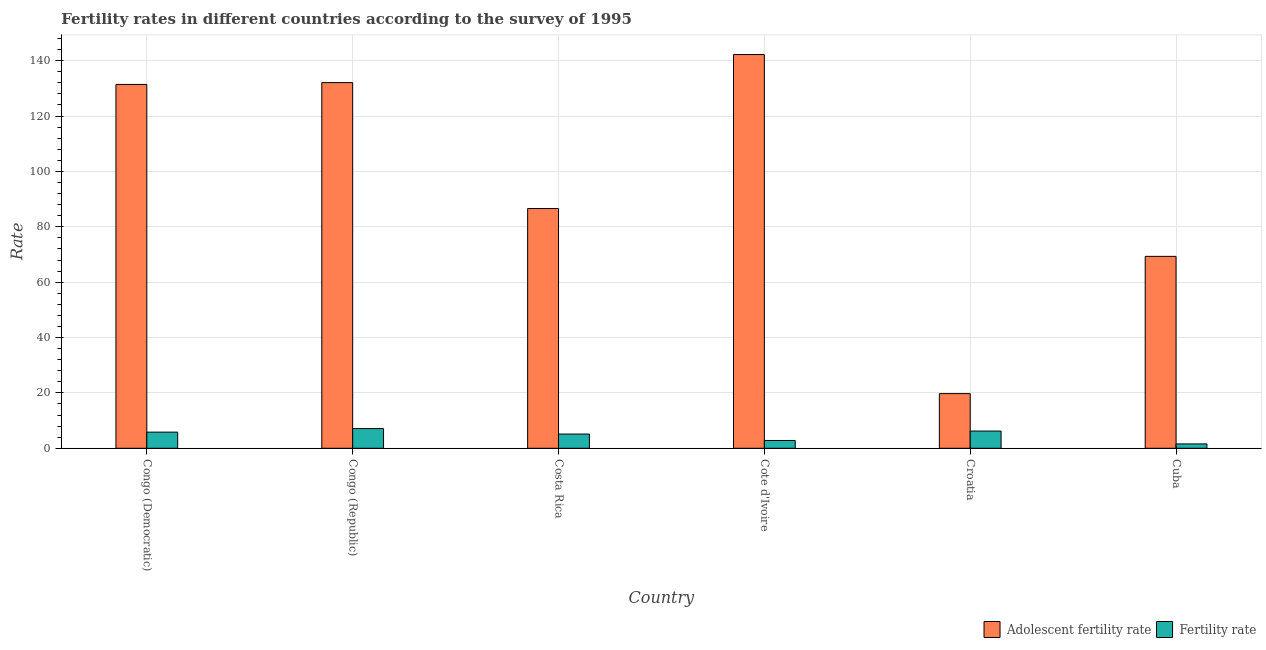How many groups of bars are there?
Provide a short and direct response. 6. Are the number of bars per tick equal to the number of legend labels?
Your response must be concise. Yes. Are the number of bars on each tick of the X-axis equal?
Keep it short and to the point. Yes. How many bars are there on the 5th tick from the right?
Your response must be concise. 2. What is the label of the 4th group of bars from the left?
Offer a very short reply. Cote d'Ivoire. In how many cases, is the number of bars for a given country not equal to the number of legend labels?
Your response must be concise. 0. What is the adolescent fertility rate in Congo (Democratic)?
Offer a very short reply. 131.42. Across all countries, what is the maximum adolescent fertility rate?
Keep it short and to the point. 142.21. Across all countries, what is the minimum fertility rate?
Ensure brevity in your answer.  1.58. In which country was the adolescent fertility rate maximum?
Offer a terse response. Cote d'Ivoire. In which country was the fertility rate minimum?
Keep it short and to the point. Cuba. What is the total adolescent fertility rate in the graph?
Make the answer very short. 581.38. What is the difference between the fertility rate in Congo (Democratic) and that in Cuba?
Keep it short and to the point. 4.25. What is the difference between the adolescent fertility rate in Cuba and the fertility rate in Costa Rica?
Offer a very short reply. 64.18. What is the average fertility rate per country?
Provide a short and direct response. 4.79. What is the difference between the fertility rate and adolescent fertility rate in Costa Rica?
Your answer should be very brief. -81.46. In how many countries, is the adolescent fertility rate greater than 12 ?
Offer a terse response. 6. What is the ratio of the fertility rate in Congo (Republic) to that in Cuba?
Give a very brief answer. 4.51. Is the fertility rate in Costa Rica less than that in Cote d'Ivoire?
Offer a very short reply. No. Is the difference between the adolescent fertility rate in Costa Rica and Croatia greater than the difference between the fertility rate in Costa Rica and Croatia?
Provide a succinct answer. Yes. What is the difference between the highest and the second highest fertility rate?
Provide a short and direct response. 0.9. What is the difference between the highest and the lowest adolescent fertility rate?
Offer a very short reply. 122.48. In how many countries, is the fertility rate greater than the average fertility rate taken over all countries?
Your response must be concise. 4. What does the 2nd bar from the left in Congo (Democratic) represents?
Ensure brevity in your answer.  Fertility rate. What does the 1st bar from the right in Congo (Republic) represents?
Provide a succinct answer. Fertility rate. How many countries are there in the graph?
Your answer should be very brief. 6. What is the difference between two consecutive major ticks on the Y-axis?
Offer a very short reply. 20. Are the values on the major ticks of Y-axis written in scientific E-notation?
Offer a terse response. No. Does the graph contain any zero values?
Provide a short and direct response. No. Where does the legend appear in the graph?
Give a very brief answer. Bottom right. How many legend labels are there?
Keep it short and to the point. 2. How are the legend labels stacked?
Your answer should be very brief. Horizontal. What is the title of the graph?
Your response must be concise. Fertility rates in different countries according to the survey of 1995. Does "Male entrants" appear as one of the legend labels in the graph?
Provide a short and direct response. No. What is the label or title of the Y-axis?
Ensure brevity in your answer.  Rate. What is the Rate in Adolescent fertility rate in Congo (Democratic)?
Keep it short and to the point. 131.42. What is the Rate in Fertility rate in Congo (Democratic)?
Provide a succinct answer. 5.83. What is the Rate in Adolescent fertility rate in Congo (Republic)?
Your answer should be very brief. 132.08. What is the Rate of Fertility rate in Congo (Republic)?
Offer a very short reply. 7.12. What is the Rate of Adolescent fertility rate in Costa Rica?
Ensure brevity in your answer.  86.61. What is the Rate of Fertility rate in Costa Rica?
Offer a terse response. 5.14. What is the Rate in Adolescent fertility rate in Cote d'Ivoire?
Your answer should be very brief. 142.21. What is the Rate in Fertility rate in Cote d'Ivoire?
Offer a terse response. 2.82. What is the Rate in Adolescent fertility rate in Croatia?
Provide a succinct answer. 19.74. What is the Rate of Fertility rate in Croatia?
Offer a very short reply. 6.22. What is the Rate of Adolescent fertility rate in Cuba?
Provide a short and direct response. 69.32. What is the Rate in Fertility rate in Cuba?
Offer a very short reply. 1.58. Across all countries, what is the maximum Rate in Adolescent fertility rate?
Your answer should be compact. 142.21. Across all countries, what is the maximum Rate in Fertility rate?
Offer a terse response. 7.12. Across all countries, what is the minimum Rate in Adolescent fertility rate?
Make the answer very short. 19.74. Across all countries, what is the minimum Rate in Fertility rate?
Your answer should be compact. 1.58. What is the total Rate of Adolescent fertility rate in the graph?
Make the answer very short. 581.38. What is the total Rate of Fertility rate in the graph?
Make the answer very short. 28.72. What is the difference between the Rate in Adolescent fertility rate in Congo (Democratic) and that in Congo (Republic)?
Give a very brief answer. -0.66. What is the difference between the Rate of Fertility rate in Congo (Democratic) and that in Congo (Republic)?
Offer a terse response. -1.29. What is the difference between the Rate of Adolescent fertility rate in Congo (Democratic) and that in Costa Rica?
Provide a succinct answer. 44.82. What is the difference between the Rate in Fertility rate in Congo (Democratic) and that in Costa Rica?
Offer a terse response. 0.69. What is the difference between the Rate in Adolescent fertility rate in Congo (Democratic) and that in Cote d'Ivoire?
Ensure brevity in your answer.  -10.79. What is the difference between the Rate in Fertility rate in Congo (Democratic) and that in Cote d'Ivoire?
Provide a succinct answer. 3.01. What is the difference between the Rate of Adolescent fertility rate in Congo (Democratic) and that in Croatia?
Ensure brevity in your answer.  111.69. What is the difference between the Rate of Fertility rate in Congo (Democratic) and that in Croatia?
Provide a short and direct response. -0.39. What is the difference between the Rate in Adolescent fertility rate in Congo (Democratic) and that in Cuba?
Offer a very short reply. 62.1. What is the difference between the Rate of Fertility rate in Congo (Democratic) and that in Cuba?
Offer a very short reply. 4.25. What is the difference between the Rate in Adolescent fertility rate in Congo (Republic) and that in Costa Rica?
Your answer should be compact. 45.48. What is the difference between the Rate of Fertility rate in Congo (Republic) and that in Costa Rica?
Ensure brevity in your answer.  1.98. What is the difference between the Rate of Adolescent fertility rate in Congo (Republic) and that in Cote d'Ivoire?
Your answer should be compact. -10.13. What is the difference between the Rate of Fertility rate in Congo (Republic) and that in Cote d'Ivoire?
Offer a very short reply. 4.3. What is the difference between the Rate in Adolescent fertility rate in Congo (Republic) and that in Croatia?
Your answer should be compact. 112.35. What is the difference between the Rate in Fertility rate in Congo (Republic) and that in Croatia?
Offer a very short reply. 0.9. What is the difference between the Rate of Adolescent fertility rate in Congo (Republic) and that in Cuba?
Your response must be concise. 62.77. What is the difference between the Rate in Fertility rate in Congo (Republic) and that in Cuba?
Offer a terse response. 5.54. What is the difference between the Rate in Adolescent fertility rate in Costa Rica and that in Cote d'Ivoire?
Offer a very short reply. -55.61. What is the difference between the Rate in Fertility rate in Costa Rica and that in Cote d'Ivoire?
Make the answer very short. 2.32. What is the difference between the Rate in Adolescent fertility rate in Costa Rica and that in Croatia?
Your response must be concise. 66.87. What is the difference between the Rate of Fertility rate in Costa Rica and that in Croatia?
Ensure brevity in your answer.  -1.08. What is the difference between the Rate in Adolescent fertility rate in Costa Rica and that in Cuba?
Offer a terse response. 17.29. What is the difference between the Rate of Fertility rate in Costa Rica and that in Cuba?
Offer a terse response. 3.56. What is the difference between the Rate in Adolescent fertility rate in Cote d'Ivoire and that in Croatia?
Your answer should be very brief. 122.48. What is the difference between the Rate of Fertility rate in Cote d'Ivoire and that in Croatia?
Provide a short and direct response. -3.4. What is the difference between the Rate in Adolescent fertility rate in Cote d'Ivoire and that in Cuba?
Provide a succinct answer. 72.9. What is the difference between the Rate of Fertility rate in Cote d'Ivoire and that in Cuba?
Provide a short and direct response. 1.24. What is the difference between the Rate of Adolescent fertility rate in Croatia and that in Cuba?
Ensure brevity in your answer.  -49.58. What is the difference between the Rate of Fertility rate in Croatia and that in Cuba?
Provide a short and direct response. 4.64. What is the difference between the Rate of Adolescent fertility rate in Congo (Democratic) and the Rate of Fertility rate in Congo (Republic)?
Your answer should be compact. 124.3. What is the difference between the Rate of Adolescent fertility rate in Congo (Democratic) and the Rate of Fertility rate in Costa Rica?
Provide a succinct answer. 126.28. What is the difference between the Rate of Adolescent fertility rate in Congo (Democratic) and the Rate of Fertility rate in Cote d'Ivoire?
Provide a succinct answer. 128.6. What is the difference between the Rate of Adolescent fertility rate in Congo (Democratic) and the Rate of Fertility rate in Croatia?
Give a very brief answer. 125.2. What is the difference between the Rate of Adolescent fertility rate in Congo (Democratic) and the Rate of Fertility rate in Cuba?
Your answer should be very brief. 129.84. What is the difference between the Rate of Adolescent fertility rate in Congo (Republic) and the Rate of Fertility rate in Costa Rica?
Provide a short and direct response. 126.94. What is the difference between the Rate of Adolescent fertility rate in Congo (Republic) and the Rate of Fertility rate in Cote d'Ivoire?
Offer a very short reply. 129.26. What is the difference between the Rate in Adolescent fertility rate in Congo (Republic) and the Rate in Fertility rate in Croatia?
Provide a succinct answer. 125.86. What is the difference between the Rate in Adolescent fertility rate in Congo (Republic) and the Rate in Fertility rate in Cuba?
Give a very brief answer. 130.5. What is the difference between the Rate in Adolescent fertility rate in Costa Rica and the Rate in Fertility rate in Cote d'Ivoire?
Provide a succinct answer. 83.78. What is the difference between the Rate of Adolescent fertility rate in Costa Rica and the Rate of Fertility rate in Croatia?
Give a very brief answer. 80.38. What is the difference between the Rate of Adolescent fertility rate in Costa Rica and the Rate of Fertility rate in Cuba?
Provide a succinct answer. 85.03. What is the difference between the Rate of Adolescent fertility rate in Cote d'Ivoire and the Rate of Fertility rate in Croatia?
Give a very brief answer. 135.99. What is the difference between the Rate in Adolescent fertility rate in Cote d'Ivoire and the Rate in Fertility rate in Cuba?
Provide a succinct answer. 140.63. What is the difference between the Rate in Adolescent fertility rate in Croatia and the Rate in Fertility rate in Cuba?
Make the answer very short. 18.16. What is the average Rate in Adolescent fertility rate per country?
Offer a terse response. 96.9. What is the average Rate of Fertility rate per country?
Make the answer very short. 4.79. What is the difference between the Rate in Adolescent fertility rate and Rate in Fertility rate in Congo (Democratic)?
Your answer should be compact. 125.59. What is the difference between the Rate of Adolescent fertility rate and Rate of Fertility rate in Congo (Republic)?
Make the answer very short. 124.96. What is the difference between the Rate of Adolescent fertility rate and Rate of Fertility rate in Costa Rica?
Your answer should be very brief. 81.46. What is the difference between the Rate of Adolescent fertility rate and Rate of Fertility rate in Cote d'Ivoire?
Offer a very short reply. 139.39. What is the difference between the Rate of Adolescent fertility rate and Rate of Fertility rate in Croatia?
Your response must be concise. 13.51. What is the difference between the Rate in Adolescent fertility rate and Rate in Fertility rate in Cuba?
Give a very brief answer. 67.74. What is the ratio of the Rate of Adolescent fertility rate in Congo (Democratic) to that in Congo (Republic)?
Offer a terse response. 0.99. What is the ratio of the Rate of Fertility rate in Congo (Democratic) to that in Congo (Republic)?
Your response must be concise. 0.82. What is the ratio of the Rate in Adolescent fertility rate in Congo (Democratic) to that in Costa Rica?
Your response must be concise. 1.52. What is the ratio of the Rate in Fertility rate in Congo (Democratic) to that in Costa Rica?
Your response must be concise. 1.13. What is the ratio of the Rate of Adolescent fertility rate in Congo (Democratic) to that in Cote d'Ivoire?
Provide a succinct answer. 0.92. What is the ratio of the Rate in Fertility rate in Congo (Democratic) to that in Cote d'Ivoire?
Offer a terse response. 2.07. What is the ratio of the Rate in Adolescent fertility rate in Congo (Democratic) to that in Croatia?
Ensure brevity in your answer.  6.66. What is the ratio of the Rate in Fertility rate in Congo (Democratic) to that in Croatia?
Make the answer very short. 0.94. What is the ratio of the Rate of Adolescent fertility rate in Congo (Democratic) to that in Cuba?
Give a very brief answer. 1.9. What is the ratio of the Rate in Fertility rate in Congo (Democratic) to that in Cuba?
Provide a succinct answer. 3.69. What is the ratio of the Rate of Adolescent fertility rate in Congo (Republic) to that in Costa Rica?
Offer a very short reply. 1.53. What is the ratio of the Rate in Fertility rate in Congo (Republic) to that in Costa Rica?
Your answer should be compact. 1.39. What is the ratio of the Rate of Adolescent fertility rate in Congo (Republic) to that in Cote d'Ivoire?
Provide a short and direct response. 0.93. What is the ratio of the Rate of Fertility rate in Congo (Republic) to that in Cote d'Ivoire?
Make the answer very short. 2.52. What is the ratio of the Rate of Adolescent fertility rate in Congo (Republic) to that in Croatia?
Your response must be concise. 6.69. What is the ratio of the Rate of Fertility rate in Congo (Republic) to that in Croatia?
Ensure brevity in your answer.  1.14. What is the ratio of the Rate of Adolescent fertility rate in Congo (Republic) to that in Cuba?
Provide a short and direct response. 1.91. What is the ratio of the Rate in Fertility rate in Congo (Republic) to that in Cuba?
Provide a short and direct response. 4.51. What is the ratio of the Rate of Adolescent fertility rate in Costa Rica to that in Cote d'Ivoire?
Provide a succinct answer. 0.61. What is the ratio of the Rate in Fertility rate in Costa Rica to that in Cote d'Ivoire?
Offer a terse response. 1.82. What is the ratio of the Rate of Adolescent fertility rate in Costa Rica to that in Croatia?
Your answer should be very brief. 4.39. What is the ratio of the Rate of Fertility rate in Costa Rica to that in Croatia?
Your response must be concise. 0.83. What is the ratio of the Rate in Adolescent fertility rate in Costa Rica to that in Cuba?
Give a very brief answer. 1.25. What is the ratio of the Rate of Fertility rate in Costa Rica to that in Cuba?
Provide a short and direct response. 3.25. What is the ratio of the Rate of Adolescent fertility rate in Cote d'Ivoire to that in Croatia?
Offer a very short reply. 7.21. What is the ratio of the Rate of Fertility rate in Cote d'Ivoire to that in Croatia?
Your answer should be compact. 0.45. What is the ratio of the Rate of Adolescent fertility rate in Cote d'Ivoire to that in Cuba?
Offer a terse response. 2.05. What is the ratio of the Rate in Fertility rate in Cote d'Ivoire to that in Cuba?
Provide a short and direct response. 1.79. What is the ratio of the Rate in Adolescent fertility rate in Croatia to that in Cuba?
Provide a succinct answer. 0.28. What is the ratio of the Rate of Fertility rate in Croatia to that in Cuba?
Offer a terse response. 3.94. What is the difference between the highest and the second highest Rate in Adolescent fertility rate?
Your response must be concise. 10.13. What is the difference between the highest and the second highest Rate of Fertility rate?
Give a very brief answer. 0.9. What is the difference between the highest and the lowest Rate of Adolescent fertility rate?
Keep it short and to the point. 122.48. What is the difference between the highest and the lowest Rate in Fertility rate?
Give a very brief answer. 5.54. 